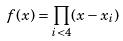<formula> <loc_0><loc_0><loc_500><loc_500>f ( x ) = \prod _ { i < 4 } ( x - x _ { i } )</formula> 